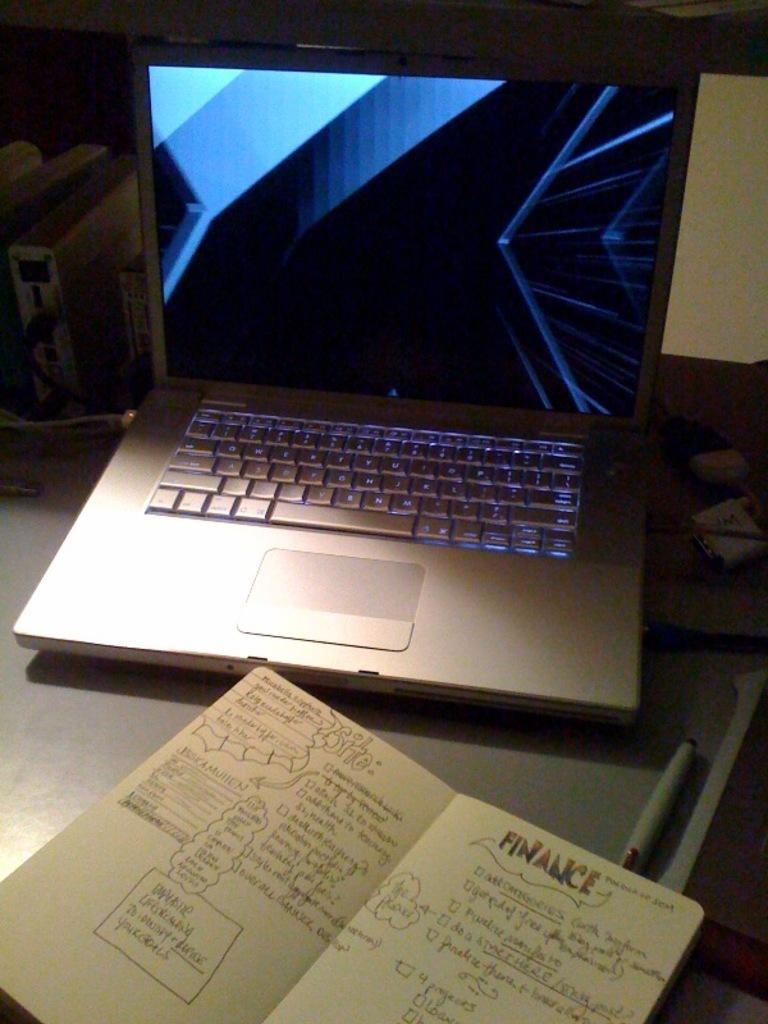What piece of furniture is in the image? There is a table in the image. What electronic device is on the table? A laptop is present on the table. What reading material is on the table? There is a book on the table. What writing instrument is visible on the table? A marker is visible on the table. What type of cloud can be seen in the image? There is no cloud present in the image, as it only features a table with a laptop, book, and marker on it. 